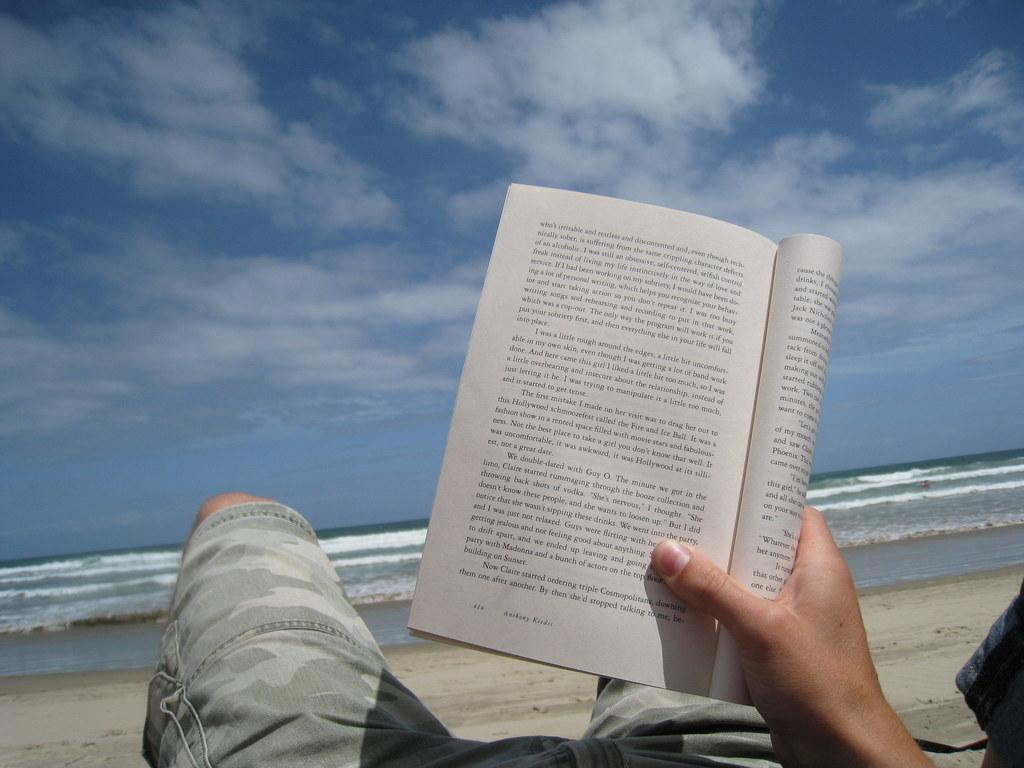Where was the image taken? The image was taken at the beach. What is the main subject in the image? There is a man in the center of the image. What is the man doing in the image? The man is lying down. What is the man holding in his hand? The man is holding a book in his hand. What can be seen in the background of the image? There is a sea and sky visible in the background of the image. What type of tools does the scarecrow have in the image? There is no scarecrow present in the image; it features a man lying down at the beach. How many boats can be seen in the image? There are no boats visible in the image; it is taken at the beach with a man lying down and a sea in the background. 